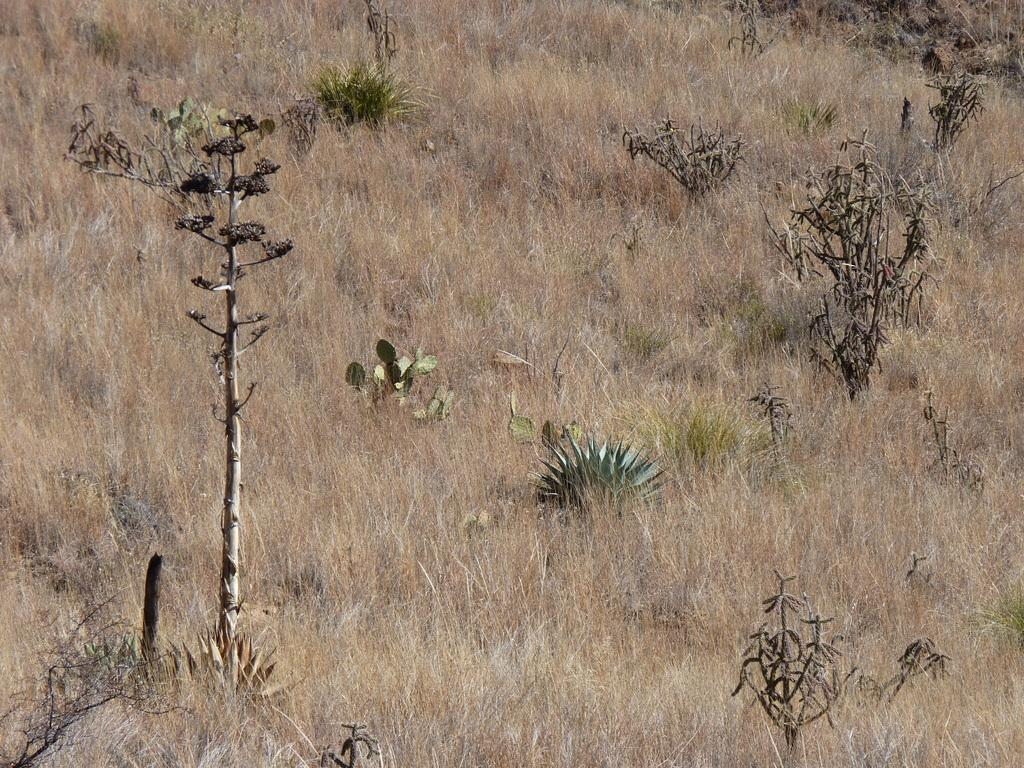What type of vegetation can be seen in the image? There are trees, plants, and grass visible in the image. Can you describe the ground in the image? The ground in the image is covered with grass. What type of fruit is hanging from the trees in the image? There is no fruit visible in the image; only trees, plants, and grass can be seen. 